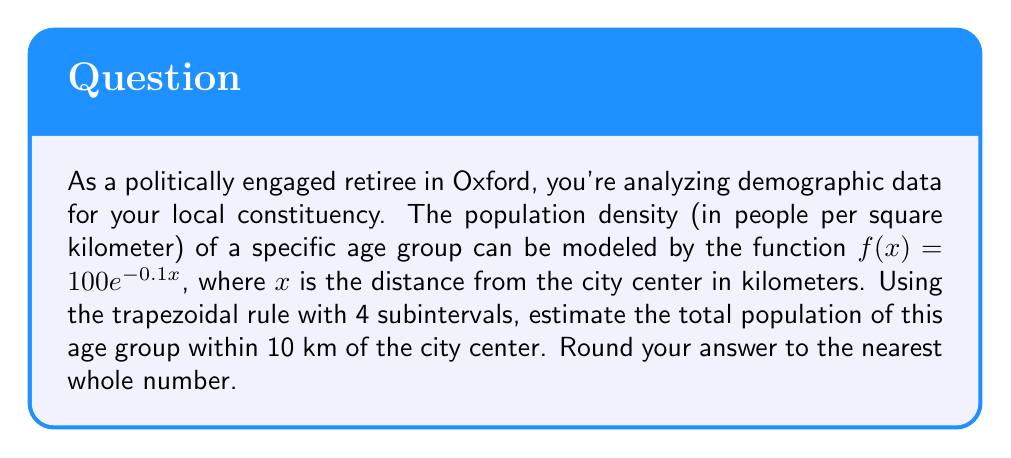Teach me how to tackle this problem. To solve this problem, we'll use the trapezoidal rule for numerical integration:

1) The trapezoidal rule formula for n subintervals is:
   $$\int_{a}^{b} f(x) dx \approx \frac{b-a}{2n}[f(a) + 2f(x_1) + 2f(x_2) + ... + 2f(x_{n-1}) + f(b)]$$

2) We're integrating from 0 to 10 km, with 4 subintervals. So:
   $a = 0$, $b = 10$, $n = 4$

3) Calculate the width of each subinterval:
   $h = \frac{b-a}{n} = \frac{10-0}{4} = 2.5$ km

4) Calculate the x-values for each point:
   $x_0 = 0$, $x_1 = 2.5$, $x_2 = 5$, $x_3 = 7.5$, $x_4 = 10$

5) Calculate $f(x)$ for each point:
   $f(0) = 100e^{-0.1(0)} = 100$
   $f(2.5) = 100e^{-0.1(2.5)} \approx 77.88$
   $f(5) = 100e^{-0.1(5)} \approx 60.65$
   $f(7.5) = 100e^{-0.1(7.5)} \approx 47.24$
   $f(10) = 100e^{-0.1(10)} \approx 36.79$

6) Apply the trapezoidal rule:
   $$\text{Area} \approx \frac{10-0}{2(4)}[100 + 2(77.88) + 2(60.65) + 2(47.24) + 36.79]$$
   $$= 1.25[100 + 155.76 + 121.30 + 94.48 + 36.79]$$
   $$= 1.25(508.33) \approx 635.41$$

7) This gives us the area under the curve, which represents population density. To get the total population, we need to multiply by $2\pi$ (as we're integrating over a circular area):
   $$\text{Population} = 635.41 \times 2\pi \approx 3990.76$$

8) Rounding to the nearest whole number: 3991
Answer: 3991 